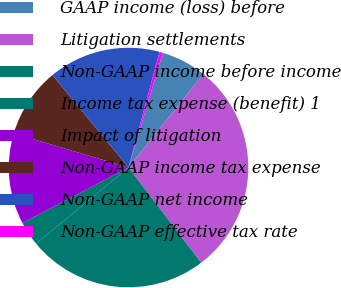Convert chart. <chart><loc_0><loc_0><loc_500><loc_500><pie_chart><fcel>GAAP income (loss) before<fcel>Litigation settlements<fcel>Non-GAAP income before income<fcel>Income tax expense (benefit) 1<fcel>Impact of litigation<fcel>Non-GAAP income tax expense<fcel>Non-GAAP net income<fcel>Non-GAAP effective tax rate<nl><fcel>6.13%<fcel>28.87%<fcel>24.41%<fcel>3.29%<fcel>12.28%<fcel>9.44%<fcel>15.12%<fcel>0.45%<nl></chart> 